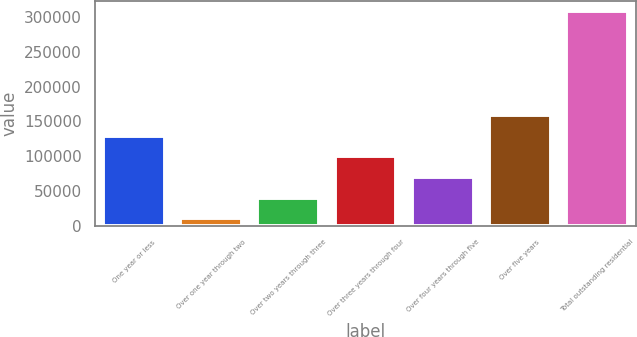<chart> <loc_0><loc_0><loc_500><loc_500><bar_chart><fcel>One year or less<fcel>Over one year through two<fcel>Over two years through three<fcel>Over three years through four<fcel>Over four years through five<fcel>Over five years<fcel>Total outstanding residential<nl><fcel>129633<fcel>10830<fcel>40530.7<fcel>99932.1<fcel>70231.4<fcel>159334<fcel>307837<nl></chart> 